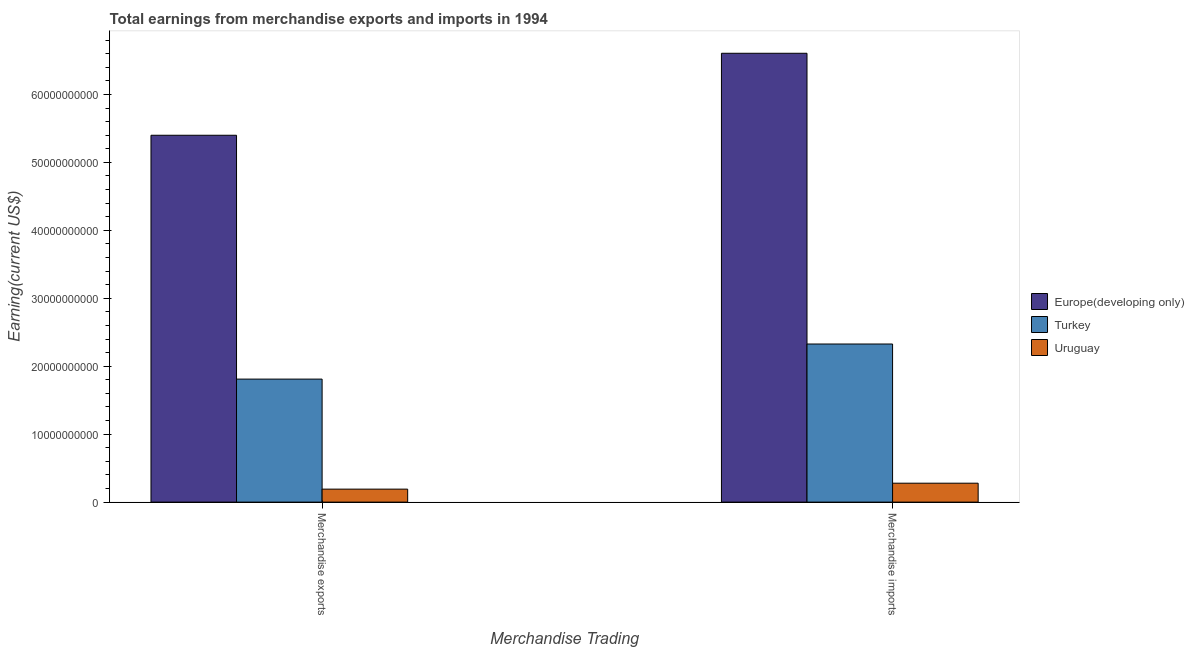How many different coloured bars are there?
Give a very brief answer. 3. How many groups of bars are there?
Keep it short and to the point. 2. Are the number of bars per tick equal to the number of legend labels?
Your response must be concise. Yes. How many bars are there on the 2nd tick from the left?
Your response must be concise. 3. How many bars are there on the 1st tick from the right?
Your answer should be very brief. 3. What is the label of the 1st group of bars from the left?
Provide a succinct answer. Merchandise exports. What is the earnings from merchandise exports in Uruguay?
Your answer should be compact. 1.91e+09. Across all countries, what is the maximum earnings from merchandise imports?
Make the answer very short. 6.61e+1. Across all countries, what is the minimum earnings from merchandise imports?
Provide a short and direct response. 2.79e+09. In which country was the earnings from merchandise exports maximum?
Offer a very short reply. Europe(developing only). In which country was the earnings from merchandise imports minimum?
Your response must be concise. Uruguay. What is the total earnings from merchandise imports in the graph?
Give a very brief answer. 9.21e+1. What is the difference between the earnings from merchandise imports in Turkey and that in Europe(developing only)?
Make the answer very short. -4.28e+1. What is the difference between the earnings from merchandise exports in Turkey and the earnings from merchandise imports in Europe(developing only)?
Ensure brevity in your answer.  -4.80e+1. What is the average earnings from merchandise imports per country?
Your answer should be compact. 3.07e+1. What is the difference between the earnings from merchandise exports and earnings from merchandise imports in Europe(developing only)?
Your answer should be compact. -1.21e+1. What is the ratio of the earnings from merchandise exports in Europe(developing only) to that in Turkey?
Give a very brief answer. 2.98. Is the earnings from merchandise imports in Uruguay less than that in Turkey?
Ensure brevity in your answer.  Yes. What does the 3rd bar from the left in Merchandise imports represents?
Offer a terse response. Uruguay. What is the difference between two consecutive major ticks on the Y-axis?
Your answer should be very brief. 1.00e+1. Does the graph contain grids?
Provide a succinct answer. No. Where does the legend appear in the graph?
Make the answer very short. Center right. How many legend labels are there?
Make the answer very short. 3. How are the legend labels stacked?
Give a very brief answer. Vertical. What is the title of the graph?
Provide a succinct answer. Total earnings from merchandise exports and imports in 1994. What is the label or title of the X-axis?
Offer a terse response. Merchandise Trading. What is the label or title of the Y-axis?
Your answer should be compact. Earning(current US$). What is the Earning(current US$) in Europe(developing only) in Merchandise exports?
Make the answer very short. 5.40e+1. What is the Earning(current US$) in Turkey in Merchandise exports?
Your response must be concise. 1.81e+1. What is the Earning(current US$) in Uruguay in Merchandise exports?
Keep it short and to the point. 1.91e+09. What is the Earning(current US$) of Europe(developing only) in Merchandise imports?
Offer a terse response. 6.61e+1. What is the Earning(current US$) in Turkey in Merchandise imports?
Give a very brief answer. 2.33e+1. What is the Earning(current US$) of Uruguay in Merchandise imports?
Provide a short and direct response. 2.79e+09. Across all Merchandise Trading, what is the maximum Earning(current US$) in Europe(developing only)?
Provide a succinct answer. 6.61e+1. Across all Merchandise Trading, what is the maximum Earning(current US$) of Turkey?
Your response must be concise. 2.33e+1. Across all Merchandise Trading, what is the maximum Earning(current US$) in Uruguay?
Your answer should be compact. 2.79e+09. Across all Merchandise Trading, what is the minimum Earning(current US$) of Europe(developing only)?
Make the answer very short. 5.40e+1. Across all Merchandise Trading, what is the minimum Earning(current US$) of Turkey?
Make the answer very short. 1.81e+1. Across all Merchandise Trading, what is the minimum Earning(current US$) in Uruguay?
Your answer should be compact. 1.91e+09. What is the total Earning(current US$) of Europe(developing only) in the graph?
Your response must be concise. 1.20e+11. What is the total Earning(current US$) in Turkey in the graph?
Your answer should be compact. 4.14e+1. What is the total Earning(current US$) of Uruguay in the graph?
Make the answer very short. 4.70e+09. What is the difference between the Earning(current US$) in Europe(developing only) in Merchandise exports and that in Merchandise imports?
Offer a very short reply. -1.21e+1. What is the difference between the Earning(current US$) of Turkey in Merchandise exports and that in Merchandise imports?
Your answer should be very brief. -5.16e+09. What is the difference between the Earning(current US$) of Uruguay in Merchandise exports and that in Merchandise imports?
Give a very brief answer. -8.73e+08. What is the difference between the Earning(current US$) in Europe(developing only) in Merchandise exports and the Earning(current US$) in Turkey in Merchandise imports?
Make the answer very short. 3.07e+1. What is the difference between the Earning(current US$) of Europe(developing only) in Merchandise exports and the Earning(current US$) of Uruguay in Merchandise imports?
Provide a succinct answer. 5.12e+1. What is the difference between the Earning(current US$) in Turkey in Merchandise exports and the Earning(current US$) in Uruguay in Merchandise imports?
Offer a very short reply. 1.53e+1. What is the average Earning(current US$) in Europe(developing only) per Merchandise Trading?
Give a very brief answer. 6.00e+1. What is the average Earning(current US$) in Turkey per Merchandise Trading?
Make the answer very short. 2.07e+1. What is the average Earning(current US$) in Uruguay per Merchandise Trading?
Your response must be concise. 2.35e+09. What is the difference between the Earning(current US$) of Europe(developing only) and Earning(current US$) of Turkey in Merchandise exports?
Offer a terse response. 3.59e+1. What is the difference between the Earning(current US$) in Europe(developing only) and Earning(current US$) in Uruguay in Merchandise exports?
Make the answer very short. 5.21e+1. What is the difference between the Earning(current US$) of Turkey and Earning(current US$) of Uruguay in Merchandise exports?
Your response must be concise. 1.62e+1. What is the difference between the Earning(current US$) in Europe(developing only) and Earning(current US$) in Turkey in Merchandise imports?
Provide a short and direct response. 4.28e+1. What is the difference between the Earning(current US$) in Europe(developing only) and Earning(current US$) in Uruguay in Merchandise imports?
Keep it short and to the point. 6.33e+1. What is the difference between the Earning(current US$) in Turkey and Earning(current US$) in Uruguay in Merchandise imports?
Give a very brief answer. 2.05e+1. What is the ratio of the Earning(current US$) of Europe(developing only) in Merchandise exports to that in Merchandise imports?
Offer a terse response. 0.82. What is the ratio of the Earning(current US$) in Turkey in Merchandise exports to that in Merchandise imports?
Your answer should be compact. 0.78. What is the ratio of the Earning(current US$) of Uruguay in Merchandise exports to that in Merchandise imports?
Your answer should be very brief. 0.69. What is the difference between the highest and the second highest Earning(current US$) in Europe(developing only)?
Offer a terse response. 1.21e+1. What is the difference between the highest and the second highest Earning(current US$) of Turkey?
Make the answer very short. 5.16e+09. What is the difference between the highest and the second highest Earning(current US$) of Uruguay?
Provide a short and direct response. 8.73e+08. What is the difference between the highest and the lowest Earning(current US$) of Europe(developing only)?
Offer a terse response. 1.21e+1. What is the difference between the highest and the lowest Earning(current US$) in Turkey?
Your answer should be very brief. 5.16e+09. What is the difference between the highest and the lowest Earning(current US$) of Uruguay?
Make the answer very short. 8.73e+08. 